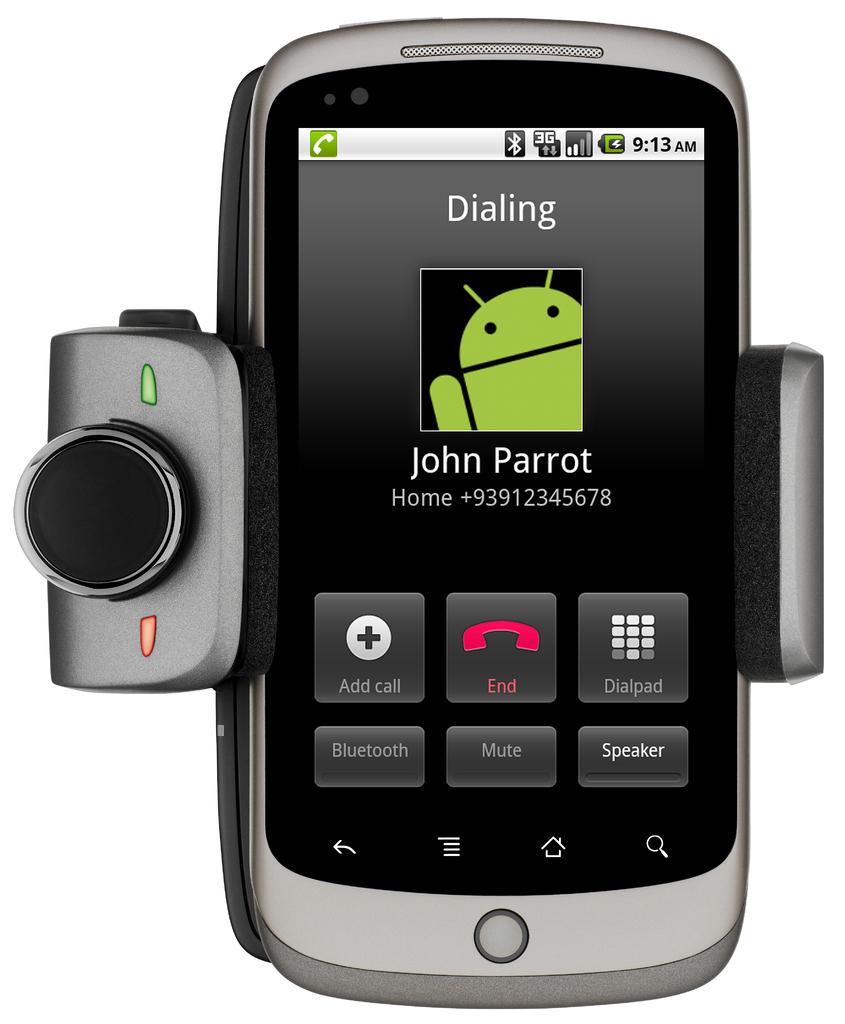What is the contact name on the phone?
Your answer should be compact. John parrot. What time is it?
Give a very brief answer. 9:13. 